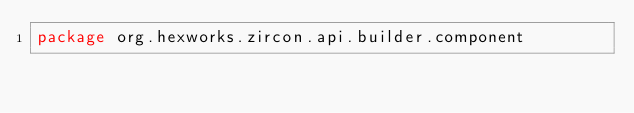Convert code to text. <code><loc_0><loc_0><loc_500><loc_500><_Kotlin_>package org.hexworks.zircon.api.builder.component
</code> 